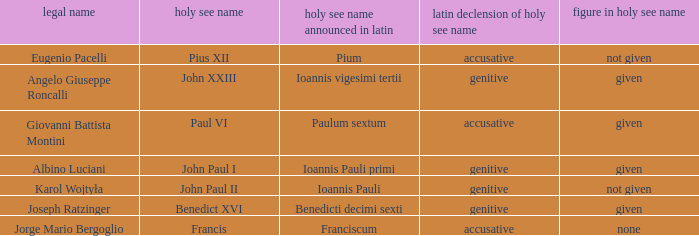What numeral is included for the pope with papal name in Latin of Ioannis Pauli? Not given. 